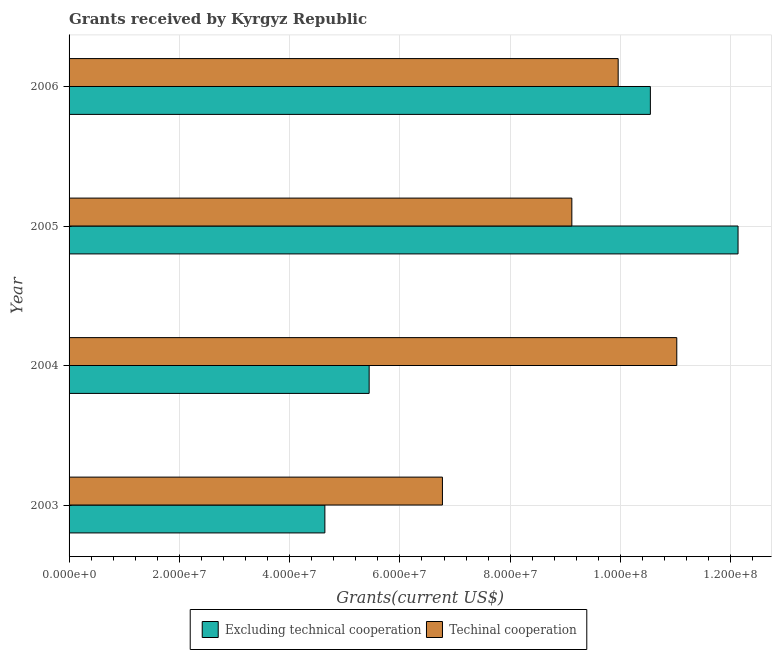How many groups of bars are there?
Provide a short and direct response. 4. Are the number of bars per tick equal to the number of legend labels?
Your answer should be very brief. Yes. How many bars are there on the 3rd tick from the top?
Your answer should be very brief. 2. What is the label of the 3rd group of bars from the top?
Offer a very short reply. 2004. What is the amount of grants received(including technical cooperation) in 2003?
Ensure brevity in your answer.  6.77e+07. Across all years, what is the maximum amount of grants received(including technical cooperation)?
Make the answer very short. 1.10e+08. Across all years, what is the minimum amount of grants received(including technical cooperation)?
Keep it short and to the point. 6.77e+07. In which year was the amount of grants received(excluding technical cooperation) maximum?
Your answer should be compact. 2005. In which year was the amount of grants received(excluding technical cooperation) minimum?
Keep it short and to the point. 2003. What is the total amount of grants received(including technical cooperation) in the graph?
Your answer should be compact. 3.69e+08. What is the difference between the amount of grants received(excluding technical cooperation) in 2004 and that in 2006?
Provide a succinct answer. -5.10e+07. What is the difference between the amount of grants received(including technical cooperation) in 2005 and the amount of grants received(excluding technical cooperation) in 2004?
Offer a very short reply. 3.68e+07. What is the average amount of grants received(including technical cooperation) per year?
Make the answer very short. 9.22e+07. In the year 2006, what is the difference between the amount of grants received(excluding technical cooperation) and amount of grants received(including technical cooperation)?
Your answer should be compact. 5.84e+06. What is the ratio of the amount of grants received(excluding technical cooperation) in 2003 to that in 2004?
Ensure brevity in your answer.  0.85. Is the amount of grants received(excluding technical cooperation) in 2003 less than that in 2005?
Offer a very short reply. Yes. Is the difference between the amount of grants received(including technical cooperation) in 2004 and 2006 greater than the difference between the amount of grants received(excluding technical cooperation) in 2004 and 2006?
Your response must be concise. Yes. What is the difference between the highest and the second highest amount of grants received(including technical cooperation)?
Offer a very short reply. 1.06e+07. What is the difference between the highest and the lowest amount of grants received(excluding technical cooperation)?
Keep it short and to the point. 7.49e+07. What does the 2nd bar from the top in 2006 represents?
Your answer should be very brief. Excluding technical cooperation. What does the 2nd bar from the bottom in 2003 represents?
Offer a very short reply. Techinal cooperation. Are all the bars in the graph horizontal?
Provide a short and direct response. Yes. How many years are there in the graph?
Ensure brevity in your answer.  4. Does the graph contain grids?
Offer a very short reply. Yes. Where does the legend appear in the graph?
Keep it short and to the point. Bottom center. How many legend labels are there?
Give a very brief answer. 2. How are the legend labels stacked?
Make the answer very short. Horizontal. What is the title of the graph?
Make the answer very short. Grants received by Kyrgyz Republic. Does "Public funds" appear as one of the legend labels in the graph?
Keep it short and to the point. No. What is the label or title of the X-axis?
Offer a terse response. Grants(current US$). What is the label or title of the Y-axis?
Ensure brevity in your answer.  Year. What is the Grants(current US$) of Excluding technical cooperation in 2003?
Your response must be concise. 4.64e+07. What is the Grants(current US$) in Techinal cooperation in 2003?
Provide a short and direct response. 6.77e+07. What is the Grants(current US$) of Excluding technical cooperation in 2004?
Give a very brief answer. 5.44e+07. What is the Grants(current US$) in Techinal cooperation in 2004?
Provide a succinct answer. 1.10e+08. What is the Grants(current US$) in Excluding technical cooperation in 2005?
Keep it short and to the point. 1.21e+08. What is the Grants(current US$) in Techinal cooperation in 2005?
Make the answer very short. 9.12e+07. What is the Grants(current US$) of Excluding technical cooperation in 2006?
Make the answer very short. 1.05e+08. What is the Grants(current US$) in Techinal cooperation in 2006?
Provide a succinct answer. 9.96e+07. Across all years, what is the maximum Grants(current US$) of Excluding technical cooperation?
Provide a short and direct response. 1.21e+08. Across all years, what is the maximum Grants(current US$) of Techinal cooperation?
Your answer should be compact. 1.10e+08. Across all years, what is the minimum Grants(current US$) of Excluding technical cooperation?
Make the answer very short. 4.64e+07. Across all years, what is the minimum Grants(current US$) in Techinal cooperation?
Your answer should be very brief. 6.77e+07. What is the total Grants(current US$) in Excluding technical cooperation in the graph?
Ensure brevity in your answer.  3.28e+08. What is the total Grants(current US$) of Techinal cooperation in the graph?
Provide a short and direct response. 3.69e+08. What is the difference between the Grants(current US$) in Excluding technical cooperation in 2003 and that in 2004?
Your answer should be compact. -8.03e+06. What is the difference between the Grants(current US$) of Techinal cooperation in 2003 and that in 2004?
Keep it short and to the point. -4.25e+07. What is the difference between the Grants(current US$) in Excluding technical cooperation in 2003 and that in 2005?
Offer a terse response. -7.49e+07. What is the difference between the Grants(current US$) in Techinal cooperation in 2003 and that in 2005?
Your response must be concise. -2.35e+07. What is the difference between the Grants(current US$) in Excluding technical cooperation in 2003 and that in 2006?
Your answer should be very brief. -5.90e+07. What is the difference between the Grants(current US$) in Techinal cooperation in 2003 and that in 2006?
Your answer should be compact. -3.19e+07. What is the difference between the Grants(current US$) in Excluding technical cooperation in 2004 and that in 2005?
Your answer should be compact. -6.69e+07. What is the difference between the Grants(current US$) of Techinal cooperation in 2004 and that in 2005?
Give a very brief answer. 1.90e+07. What is the difference between the Grants(current US$) in Excluding technical cooperation in 2004 and that in 2006?
Your answer should be compact. -5.10e+07. What is the difference between the Grants(current US$) in Techinal cooperation in 2004 and that in 2006?
Give a very brief answer. 1.06e+07. What is the difference between the Grants(current US$) of Excluding technical cooperation in 2005 and that in 2006?
Provide a succinct answer. 1.59e+07. What is the difference between the Grants(current US$) of Techinal cooperation in 2005 and that in 2006?
Offer a very short reply. -8.40e+06. What is the difference between the Grants(current US$) in Excluding technical cooperation in 2003 and the Grants(current US$) in Techinal cooperation in 2004?
Keep it short and to the point. -6.38e+07. What is the difference between the Grants(current US$) of Excluding technical cooperation in 2003 and the Grants(current US$) of Techinal cooperation in 2005?
Your response must be concise. -4.48e+07. What is the difference between the Grants(current US$) in Excluding technical cooperation in 2003 and the Grants(current US$) in Techinal cooperation in 2006?
Keep it short and to the point. -5.32e+07. What is the difference between the Grants(current US$) in Excluding technical cooperation in 2004 and the Grants(current US$) in Techinal cooperation in 2005?
Offer a very short reply. -3.68e+07. What is the difference between the Grants(current US$) of Excluding technical cooperation in 2004 and the Grants(current US$) of Techinal cooperation in 2006?
Offer a very short reply. -4.52e+07. What is the difference between the Grants(current US$) in Excluding technical cooperation in 2005 and the Grants(current US$) in Techinal cooperation in 2006?
Offer a terse response. 2.17e+07. What is the average Grants(current US$) in Excluding technical cooperation per year?
Give a very brief answer. 8.19e+07. What is the average Grants(current US$) of Techinal cooperation per year?
Your answer should be compact. 9.22e+07. In the year 2003, what is the difference between the Grants(current US$) in Excluding technical cooperation and Grants(current US$) in Techinal cooperation?
Make the answer very short. -2.13e+07. In the year 2004, what is the difference between the Grants(current US$) of Excluding technical cooperation and Grants(current US$) of Techinal cooperation?
Offer a terse response. -5.58e+07. In the year 2005, what is the difference between the Grants(current US$) of Excluding technical cooperation and Grants(current US$) of Techinal cooperation?
Provide a succinct answer. 3.01e+07. In the year 2006, what is the difference between the Grants(current US$) of Excluding technical cooperation and Grants(current US$) of Techinal cooperation?
Your response must be concise. 5.84e+06. What is the ratio of the Grants(current US$) in Excluding technical cooperation in 2003 to that in 2004?
Your response must be concise. 0.85. What is the ratio of the Grants(current US$) of Techinal cooperation in 2003 to that in 2004?
Your response must be concise. 0.61. What is the ratio of the Grants(current US$) in Excluding technical cooperation in 2003 to that in 2005?
Provide a succinct answer. 0.38. What is the ratio of the Grants(current US$) in Techinal cooperation in 2003 to that in 2005?
Ensure brevity in your answer.  0.74. What is the ratio of the Grants(current US$) of Excluding technical cooperation in 2003 to that in 2006?
Provide a short and direct response. 0.44. What is the ratio of the Grants(current US$) of Techinal cooperation in 2003 to that in 2006?
Offer a terse response. 0.68. What is the ratio of the Grants(current US$) of Excluding technical cooperation in 2004 to that in 2005?
Make the answer very short. 0.45. What is the ratio of the Grants(current US$) in Techinal cooperation in 2004 to that in 2005?
Provide a succinct answer. 1.21. What is the ratio of the Grants(current US$) in Excluding technical cooperation in 2004 to that in 2006?
Offer a very short reply. 0.52. What is the ratio of the Grants(current US$) of Techinal cooperation in 2004 to that in 2006?
Give a very brief answer. 1.11. What is the ratio of the Grants(current US$) in Excluding technical cooperation in 2005 to that in 2006?
Your answer should be very brief. 1.15. What is the ratio of the Grants(current US$) of Techinal cooperation in 2005 to that in 2006?
Keep it short and to the point. 0.92. What is the difference between the highest and the second highest Grants(current US$) of Excluding technical cooperation?
Offer a terse response. 1.59e+07. What is the difference between the highest and the second highest Grants(current US$) in Techinal cooperation?
Provide a succinct answer. 1.06e+07. What is the difference between the highest and the lowest Grants(current US$) of Excluding technical cooperation?
Provide a succinct answer. 7.49e+07. What is the difference between the highest and the lowest Grants(current US$) of Techinal cooperation?
Provide a succinct answer. 4.25e+07. 